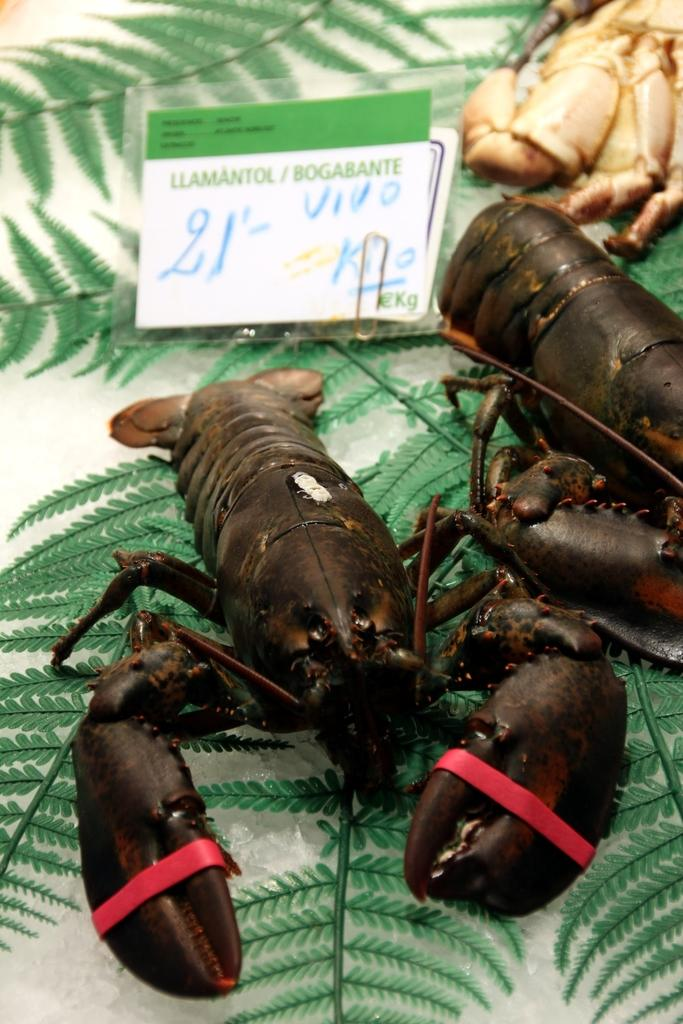What type of living organisms can be seen in the image? Insects can be seen in the image. Is there any indication of the cost or value of an item in the image? Yes, there is a price tag in the image. What type of plant material is present in the image? There are leaves in the image. What type of veil is being worn by the governor in the image? There is no governor or veil present in the image. What type of food is being served for lunch in the image? There is no lunch or food present in the image. 